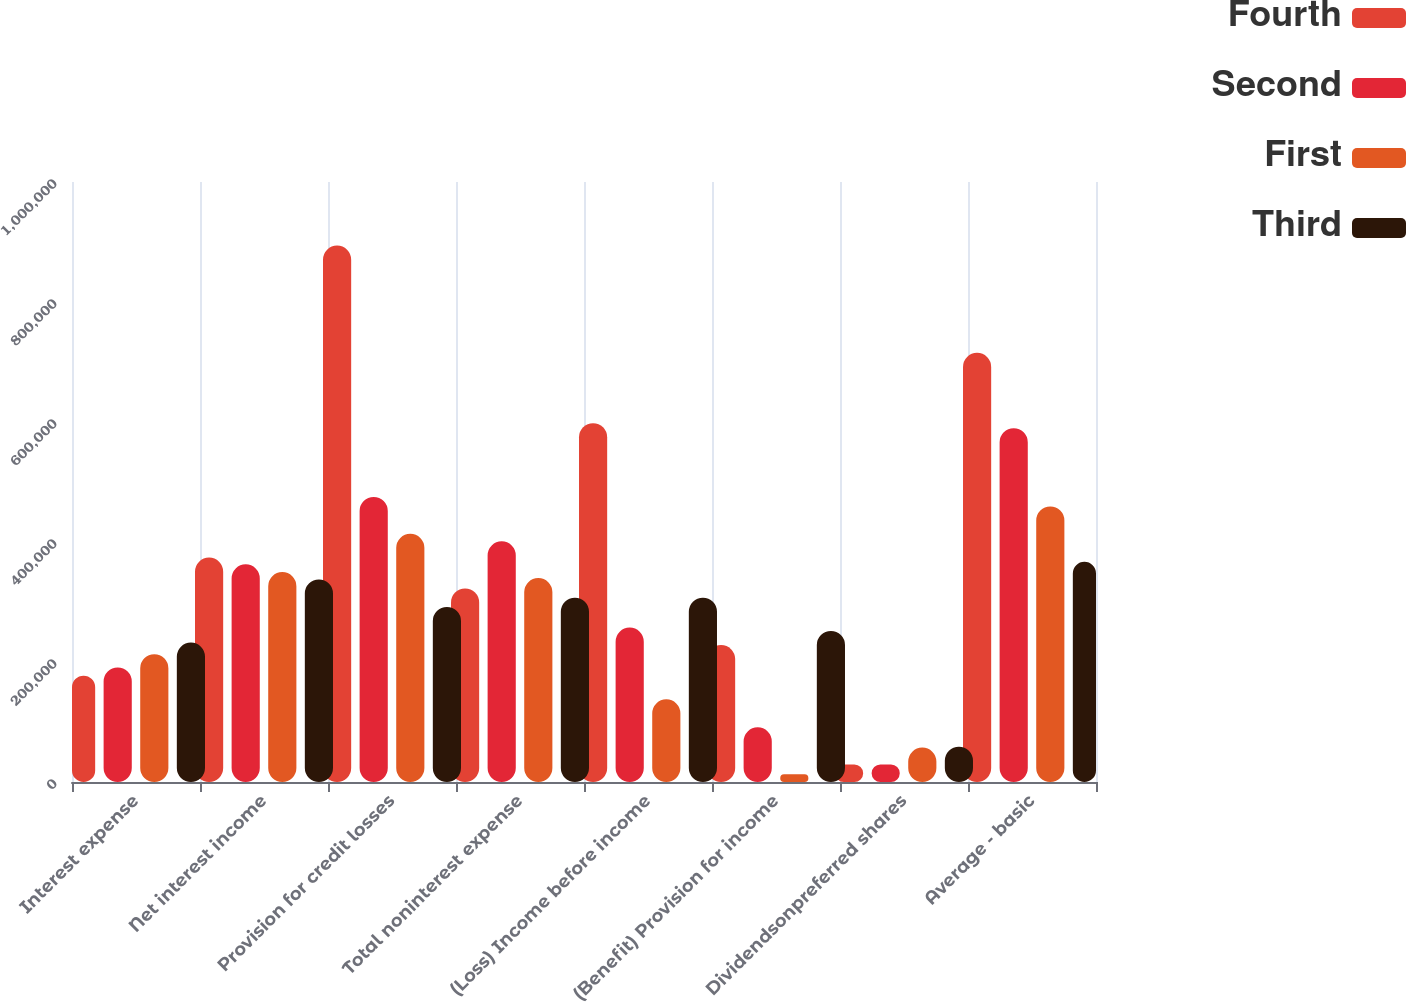Convert chart to OTSL. <chart><loc_0><loc_0><loc_500><loc_500><stacked_bar_chart><ecel><fcel>Interest expense<fcel>Net interest income<fcel>Provision for credit losses<fcel>Total noninterest expense<fcel>(Loss) Income before income<fcel>(Benefit) Provision for income<fcel>Dividendsonpreferred shares<fcel>Average - basic<nl><fcel>Fourth<fcel>177271<fcel>374064<fcel>893991<fcel>322596<fcel>597977<fcel>228290<fcel>29289<fcel>715336<nl><fcel>Second<fcel>191027<fcel>362819<fcel>475136<fcel>401097<fcel>257362<fcel>91172<fcel>29223<fcel>589708<nl><fcel>First<fcel>213105<fcel>349899<fcel>413707<fcel>339982<fcel>137845<fcel>12750<fcel>57451<fcel>459246<nl><fcel>Third<fcel>232452<fcel>337505<fcel>291837<fcel>307216<fcel>307216<fcel>251792<fcel>58793<fcel>366919<nl></chart> 